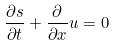Convert formula to latex. <formula><loc_0><loc_0><loc_500><loc_500>\frac { \partial s } { \partial t } + \frac { \partial } { \partial x } u = 0</formula> 